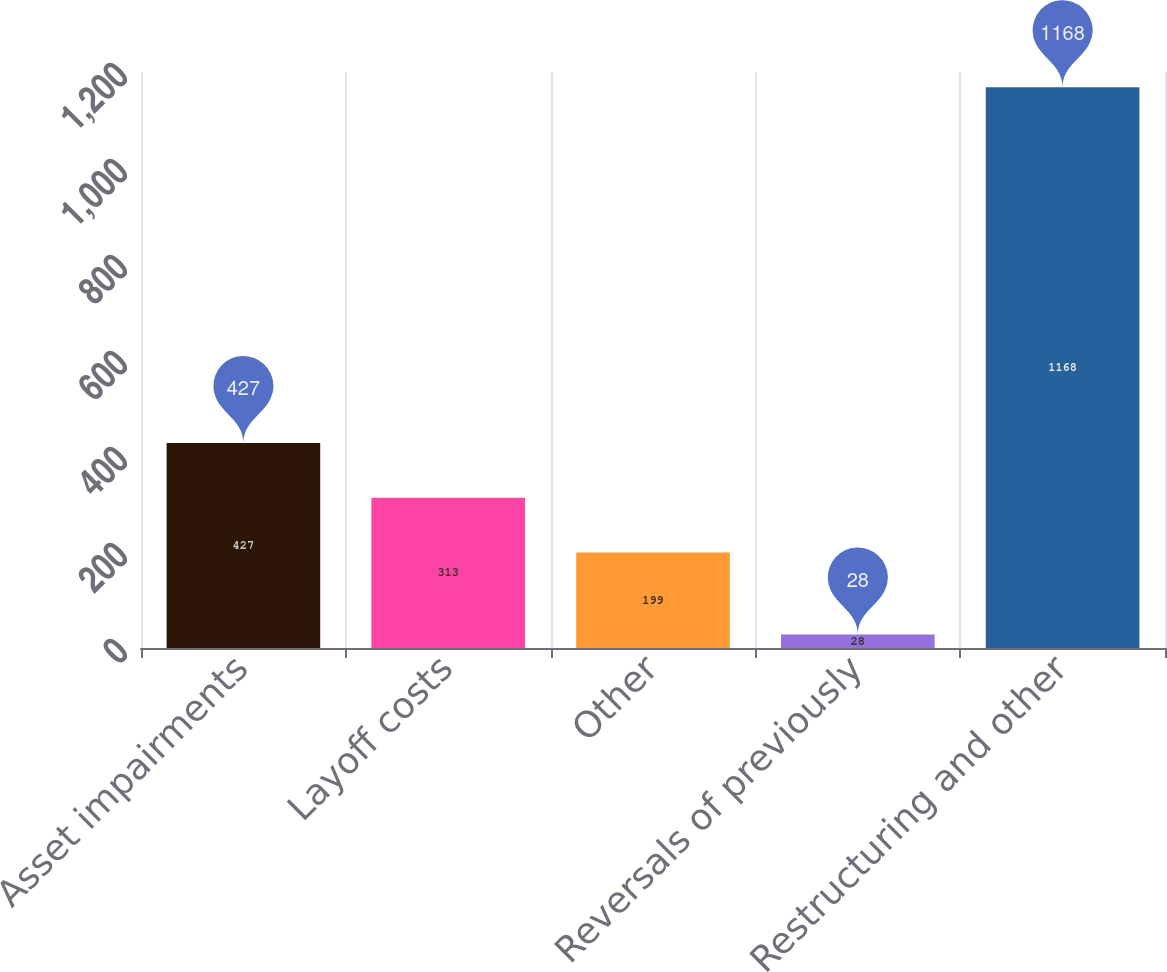Convert chart. <chart><loc_0><loc_0><loc_500><loc_500><bar_chart><fcel>Asset impairments<fcel>Layoff costs<fcel>Other<fcel>Reversals of previously<fcel>Restructuring and other<nl><fcel>427<fcel>313<fcel>199<fcel>28<fcel>1168<nl></chart> 